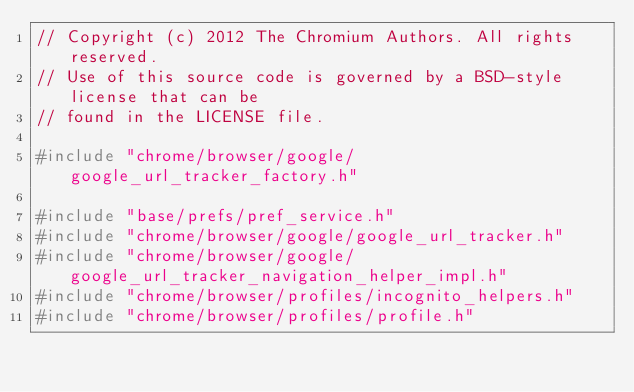<code> <loc_0><loc_0><loc_500><loc_500><_C++_>// Copyright (c) 2012 The Chromium Authors. All rights reserved.
// Use of this source code is governed by a BSD-style license that can be
// found in the LICENSE file.

#include "chrome/browser/google/google_url_tracker_factory.h"

#include "base/prefs/pref_service.h"
#include "chrome/browser/google/google_url_tracker.h"
#include "chrome/browser/google/google_url_tracker_navigation_helper_impl.h"
#include "chrome/browser/profiles/incognito_helpers.h"
#include "chrome/browser/profiles/profile.h"</code> 